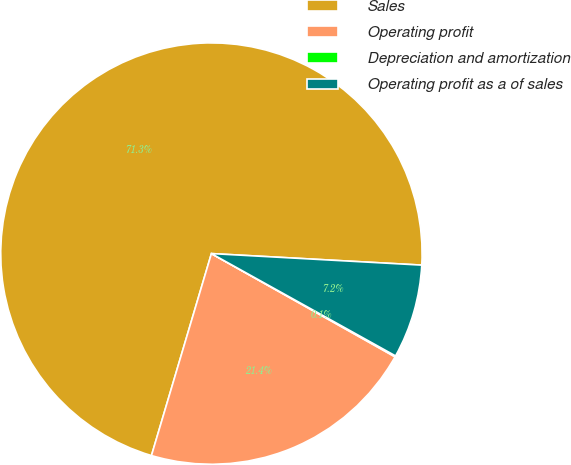Convert chart. <chart><loc_0><loc_0><loc_500><loc_500><pie_chart><fcel>Sales<fcel>Operating profit<fcel>Depreciation and amortization<fcel>Operating profit as a of sales<nl><fcel>71.28%<fcel>21.44%<fcel>0.08%<fcel>7.2%<nl></chart> 